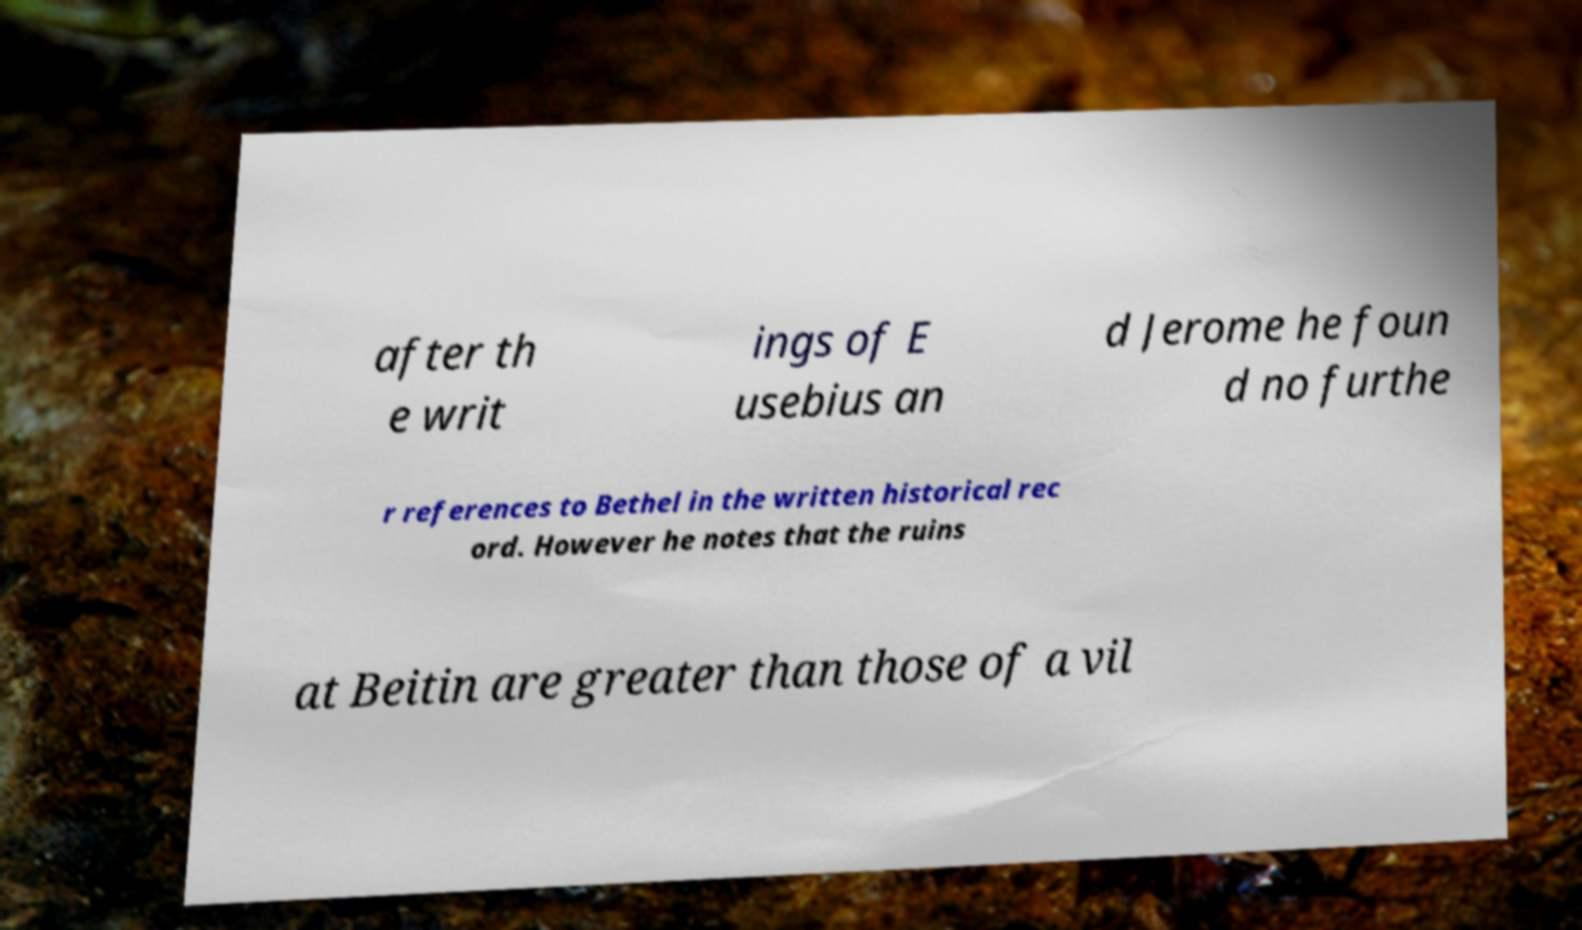Please read and relay the text visible in this image. What does it say? after th e writ ings of E usebius an d Jerome he foun d no furthe r references to Bethel in the written historical rec ord. However he notes that the ruins at Beitin are greater than those of a vil 